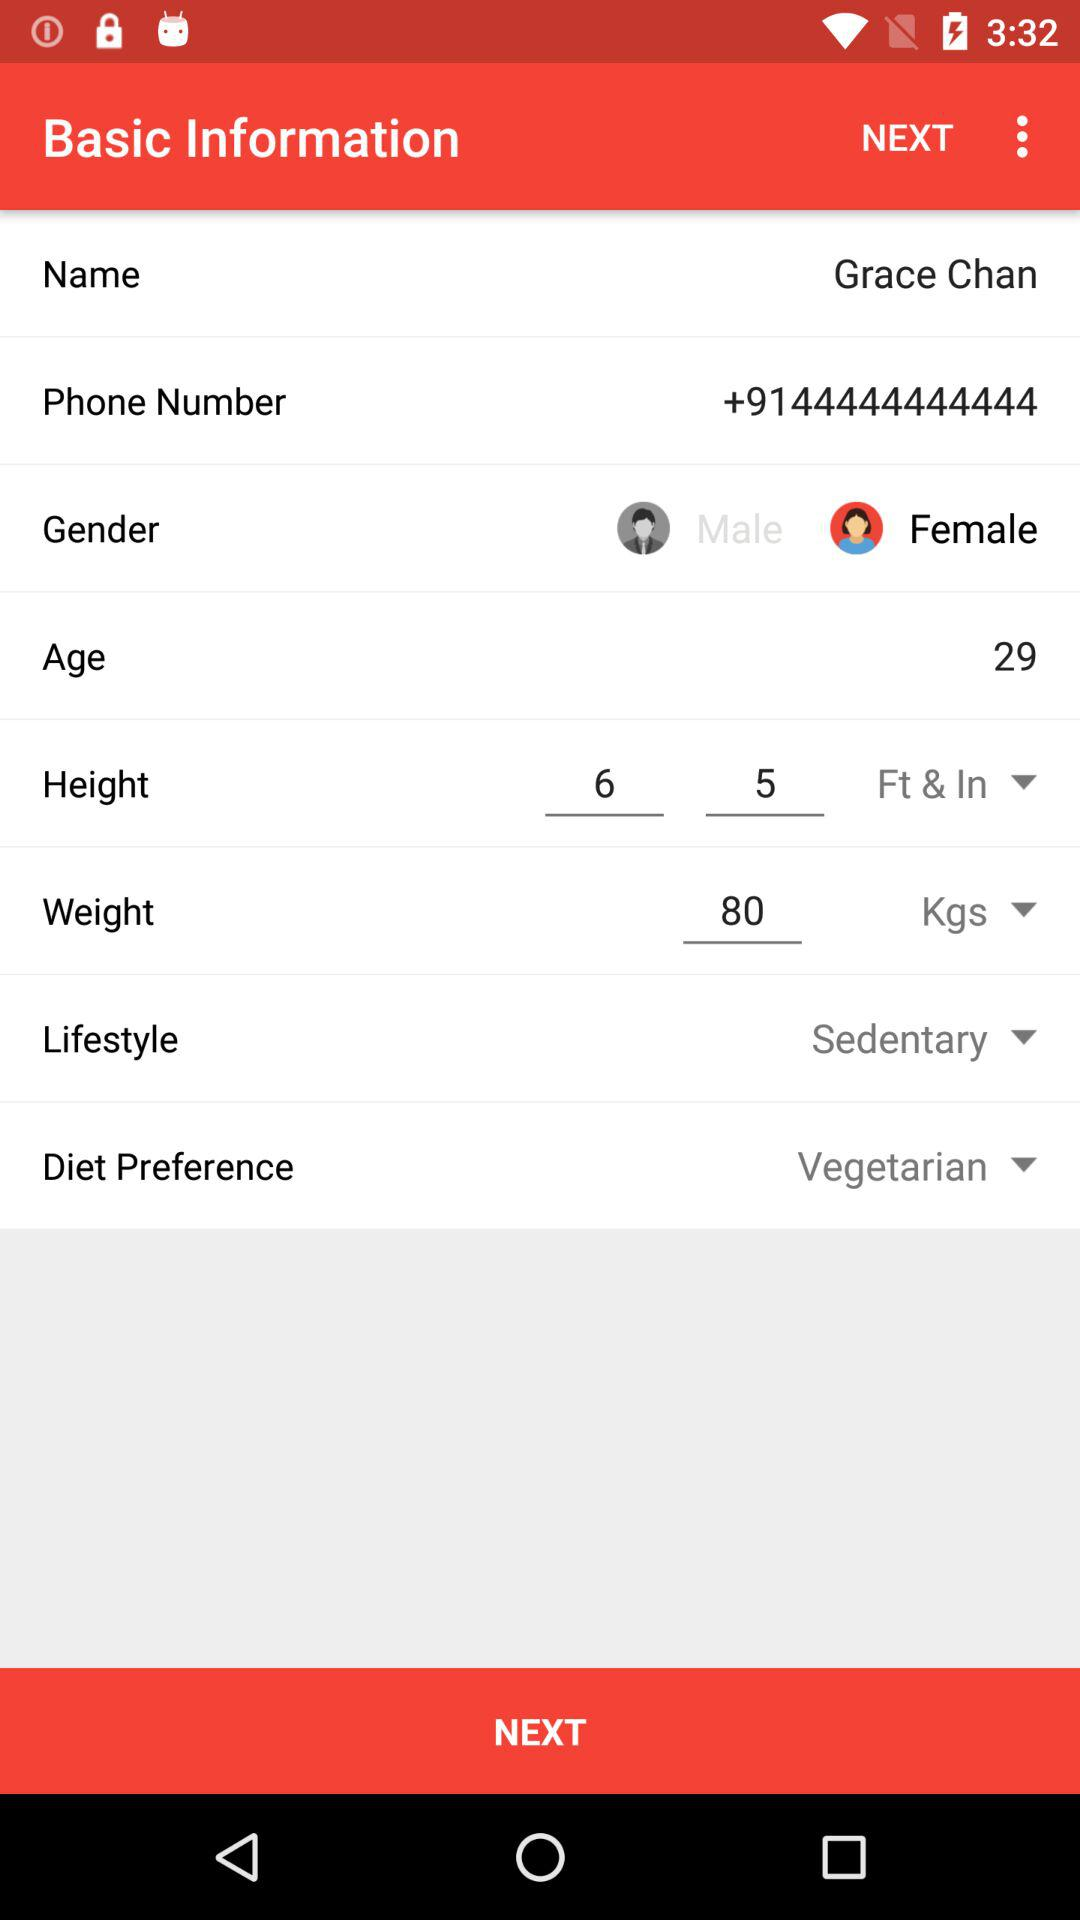How many years old is Grace Chan? Grace Chan is 29 years old. 